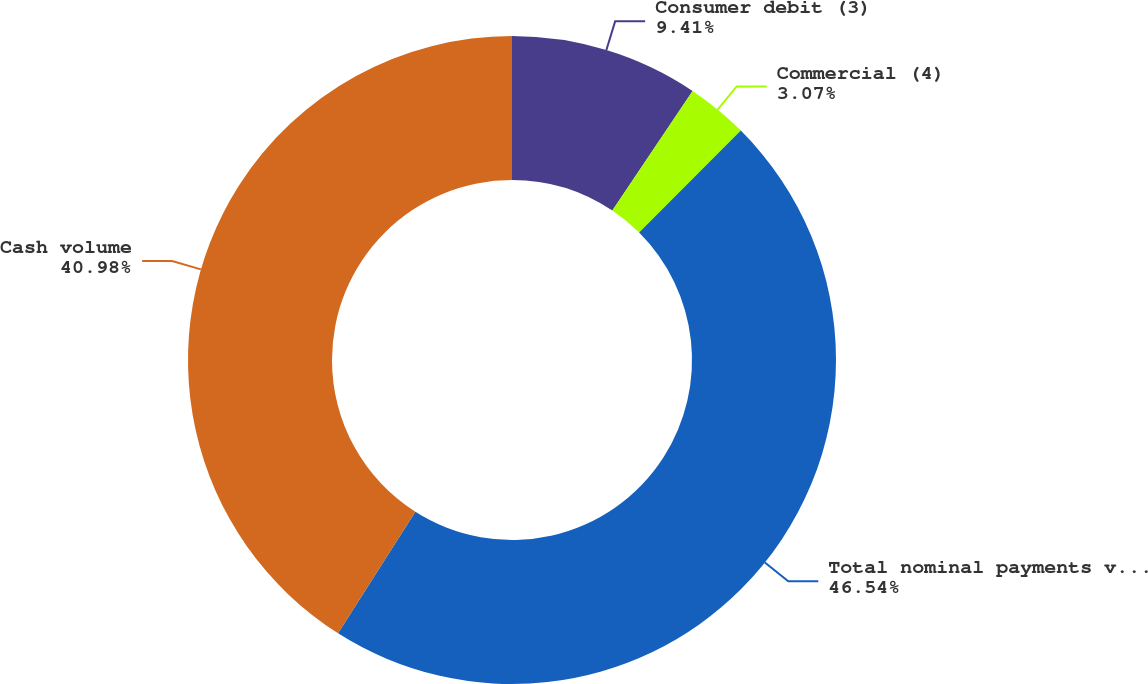Convert chart. <chart><loc_0><loc_0><loc_500><loc_500><pie_chart><fcel>Consumer debit (3)<fcel>Commercial (4)<fcel>Total nominal payments volume<fcel>Cash volume<nl><fcel>9.41%<fcel>3.07%<fcel>46.54%<fcel>40.98%<nl></chart> 